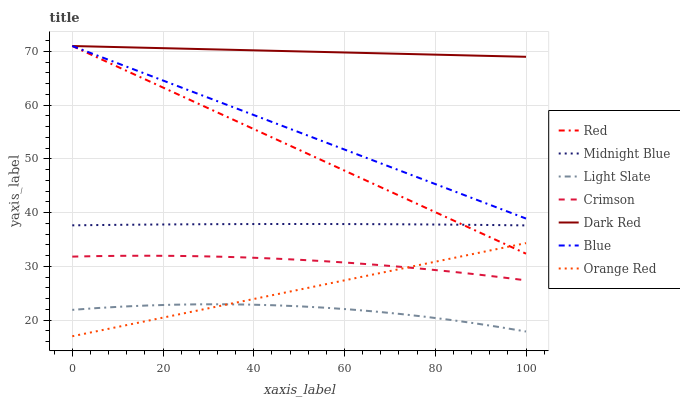Does Light Slate have the minimum area under the curve?
Answer yes or no. Yes. Does Dark Red have the maximum area under the curve?
Answer yes or no. Yes. Does Midnight Blue have the minimum area under the curve?
Answer yes or no. No. Does Midnight Blue have the maximum area under the curve?
Answer yes or no. No. Is Red the smoothest?
Answer yes or no. Yes. Is Light Slate the roughest?
Answer yes or no. Yes. Is Midnight Blue the smoothest?
Answer yes or no. No. Is Midnight Blue the roughest?
Answer yes or no. No. Does Orange Red have the lowest value?
Answer yes or no. Yes. Does Midnight Blue have the lowest value?
Answer yes or no. No. Does Red have the highest value?
Answer yes or no. Yes. Does Midnight Blue have the highest value?
Answer yes or no. No. Is Crimson less than Midnight Blue?
Answer yes or no. Yes. Is Blue greater than Crimson?
Answer yes or no. Yes. Does Blue intersect Red?
Answer yes or no. Yes. Is Blue less than Red?
Answer yes or no. No. Is Blue greater than Red?
Answer yes or no. No. Does Crimson intersect Midnight Blue?
Answer yes or no. No. 